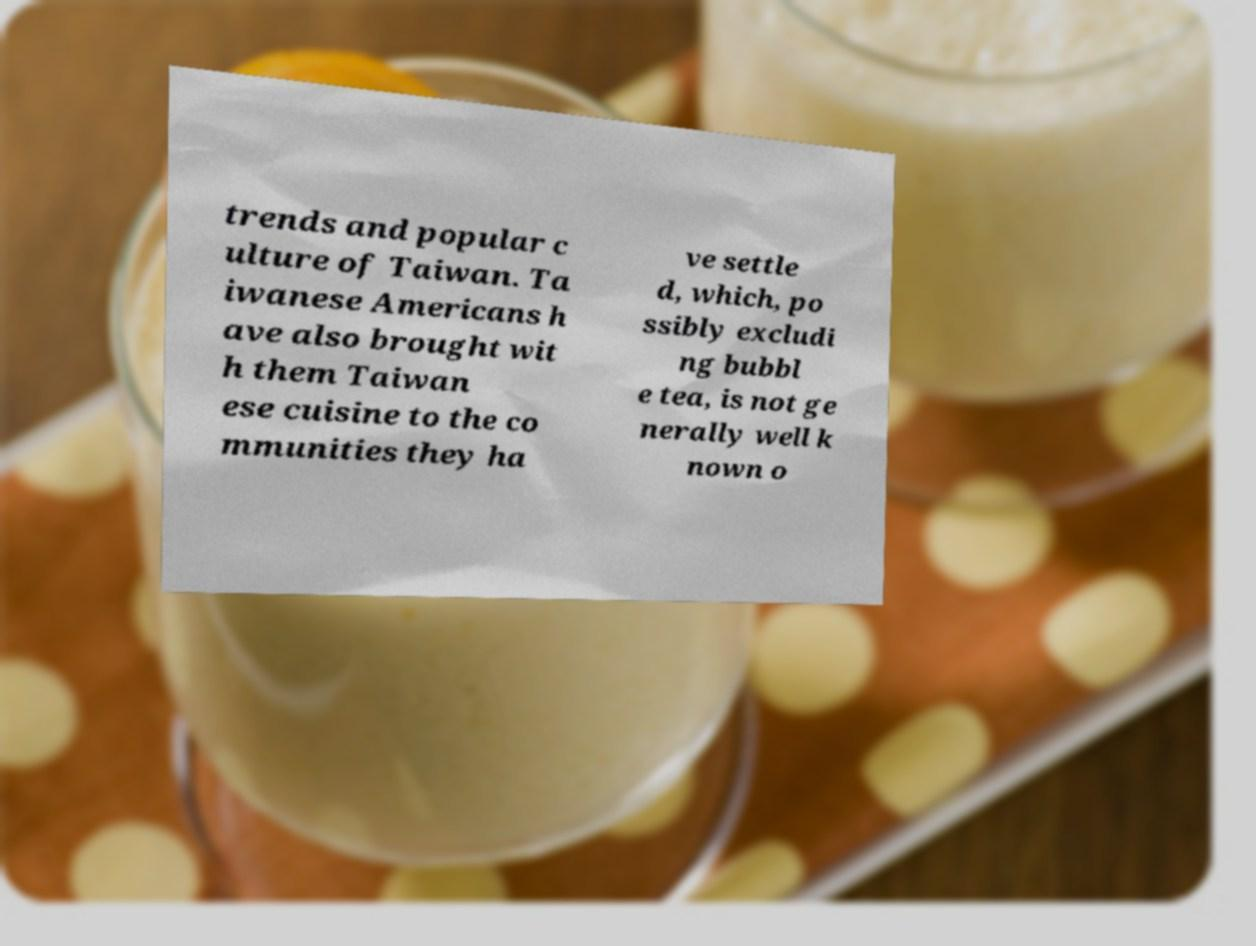Please read and relay the text visible in this image. What does it say? trends and popular c ulture of Taiwan. Ta iwanese Americans h ave also brought wit h them Taiwan ese cuisine to the co mmunities they ha ve settle d, which, po ssibly excludi ng bubbl e tea, is not ge nerally well k nown o 